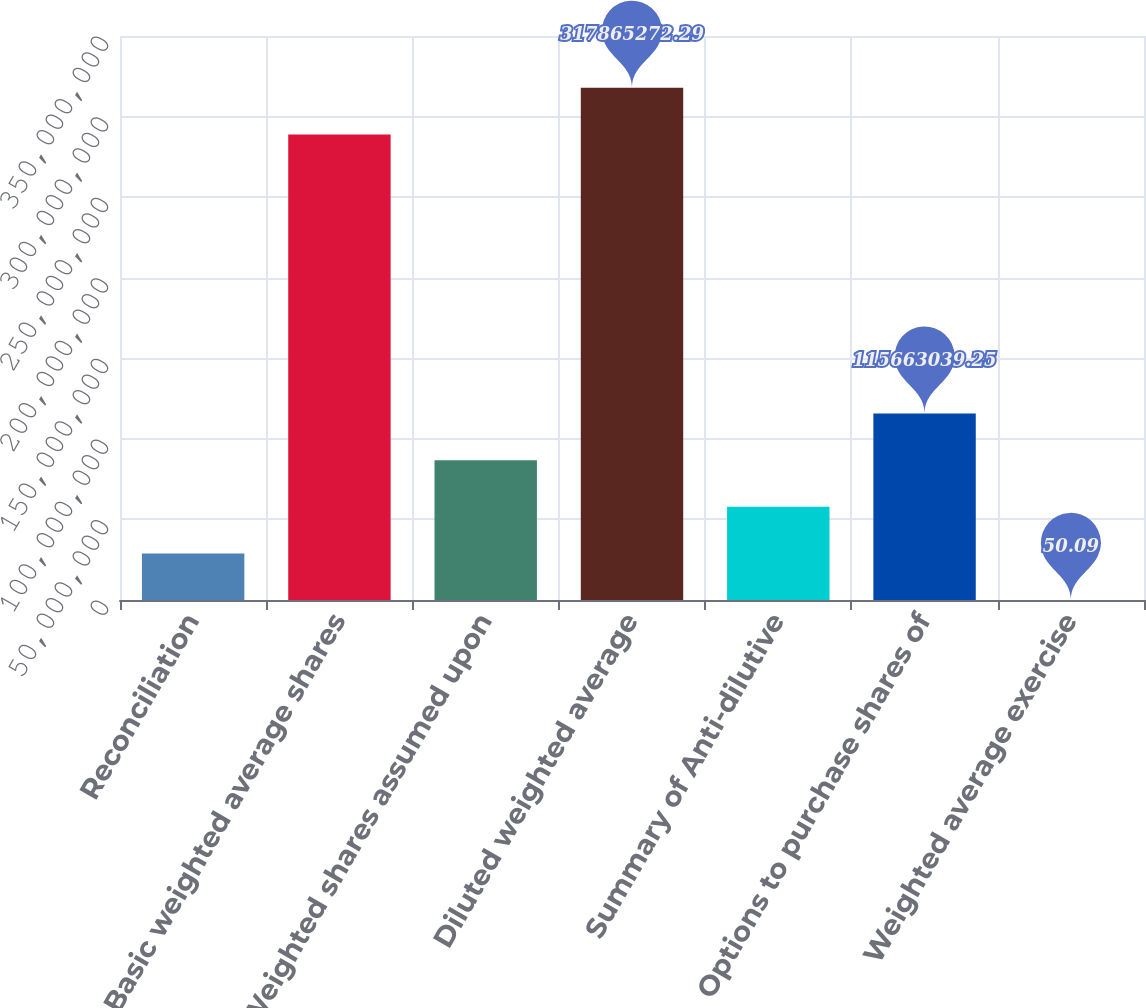Convert chart to OTSL. <chart><loc_0><loc_0><loc_500><loc_500><bar_chart><fcel>Reconciliation<fcel>Basic weighted average shares<fcel>Weighted shares assumed upon<fcel>Diluted weighted average<fcel>Summary of Anti-dilutive<fcel>Options to purchase shares of<fcel>Weighted average exercise<nl><fcel>2.89158e+07<fcel>2.8895e+08<fcel>8.67473e+07<fcel>3.17865e+08<fcel>5.78315e+07<fcel>1.15663e+08<fcel>50.09<nl></chart> 